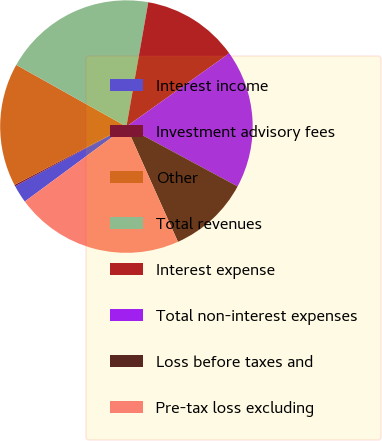Convert chart. <chart><loc_0><loc_0><loc_500><loc_500><pie_chart><fcel>Interest income<fcel>Investment advisory fees<fcel>Other<fcel>Total revenues<fcel>Interest expense<fcel>Total non-interest expenses<fcel>Loss before taxes and<fcel>Pre-tax loss excluding<nl><fcel>2.28%<fcel>0.19%<fcel>15.77%<fcel>19.65%<fcel>12.38%<fcel>17.71%<fcel>10.45%<fcel>21.58%<nl></chart> 